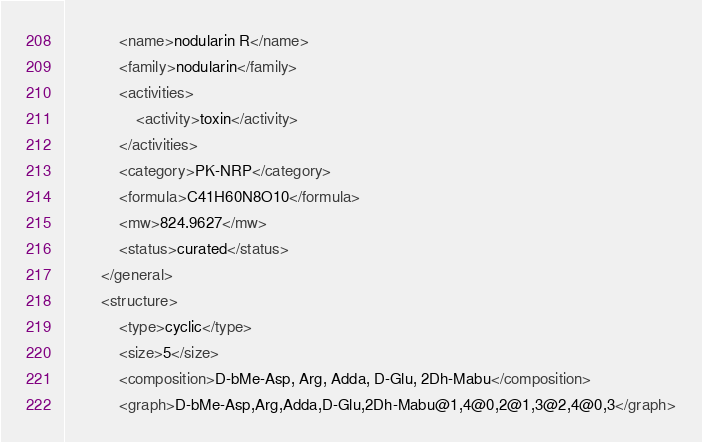<code> <loc_0><loc_0><loc_500><loc_500><_XML_>            <name>nodularin R</name>
            <family>nodularin</family>
            <activities>
                <activity>toxin</activity>
            </activities>
            <category>PK-NRP</category>
            <formula>C41H60N8O10</formula>
            <mw>824.9627</mw>
            <status>curated</status>
        </general>
        <structure>
            <type>cyclic</type>
            <size>5</size>
            <composition>D-bMe-Asp, Arg, Adda, D-Glu, 2Dh-Mabu</composition>
            <graph>D-bMe-Asp,Arg,Adda,D-Glu,2Dh-Mabu@1,4@0,2@1,3@2,4@0,3</graph></code> 